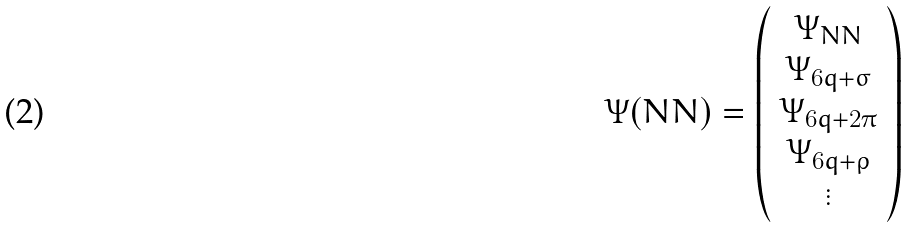Convert formula to latex. <formula><loc_0><loc_0><loc_500><loc_500>\Psi ( N N ) = \left ( \begin{array} { c } \Psi _ { N N } \\ \Psi _ { 6 q + \sigma } \\ \Psi _ { 6 q + 2 \pi } \\ \Psi _ { 6 q + \rho } \\ \vdots \end{array} \right )</formula> 